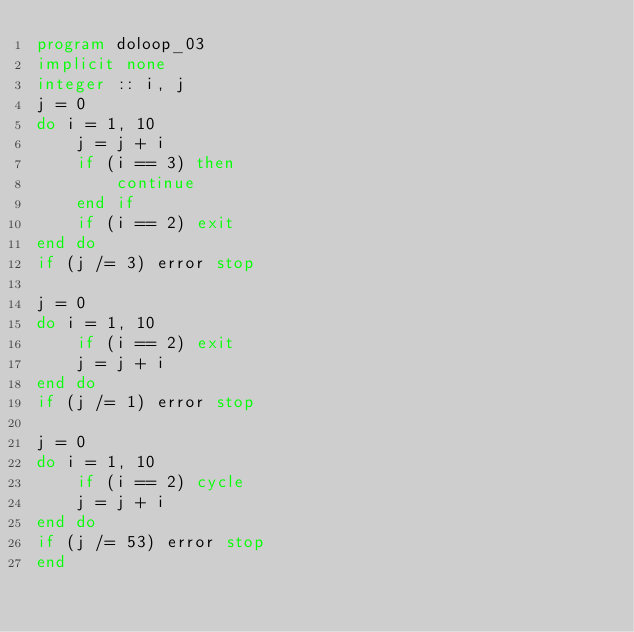Convert code to text. <code><loc_0><loc_0><loc_500><loc_500><_FORTRAN_>program doloop_03
implicit none
integer :: i, j
j = 0
do i = 1, 10
    j = j + i
    if (i == 3) then
        continue
    end if
    if (i == 2) exit
end do
if (j /= 3) error stop

j = 0
do i = 1, 10
    if (i == 2) exit
    j = j + i
end do
if (j /= 1) error stop

j = 0
do i = 1, 10
    if (i == 2) cycle
    j = j + i
end do
if (j /= 53) error stop
end
</code> 